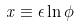<formula> <loc_0><loc_0><loc_500><loc_500>x \equiv \epsilon \ln \phi</formula> 